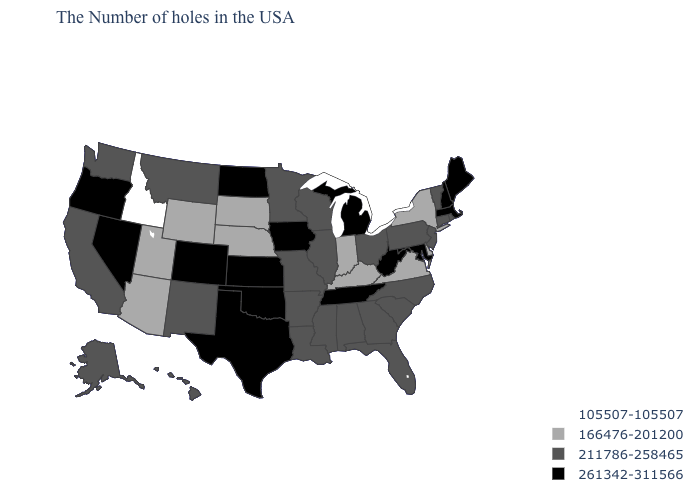Does North Carolina have a higher value than Arizona?
Keep it brief. Yes. Among the states that border Alabama , which have the highest value?
Short answer required. Tennessee. What is the value of Georgia?
Write a very short answer. 211786-258465. What is the highest value in the MidWest ?
Be succinct. 261342-311566. What is the lowest value in the USA?
Be succinct. 105507-105507. Name the states that have a value in the range 261342-311566?
Keep it brief. Maine, Massachusetts, New Hampshire, Maryland, West Virginia, Michigan, Tennessee, Iowa, Kansas, Oklahoma, Texas, North Dakota, Colorado, Nevada, Oregon. Does Georgia have the lowest value in the South?
Write a very short answer. No. Name the states that have a value in the range 105507-105507?
Quick response, please. Idaho. Which states have the highest value in the USA?
Answer briefly. Maine, Massachusetts, New Hampshire, Maryland, West Virginia, Michigan, Tennessee, Iowa, Kansas, Oklahoma, Texas, North Dakota, Colorado, Nevada, Oregon. What is the value of New Mexico?
Quick response, please. 211786-258465. What is the highest value in the West ?
Answer briefly. 261342-311566. What is the value of Oregon?
Short answer required. 261342-311566. What is the value of Louisiana?
Quick response, please. 211786-258465. Does Oregon have the highest value in the West?
Write a very short answer. Yes. Does Delaware have the highest value in the USA?
Give a very brief answer. No. 